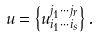<formula> <loc_0><loc_0><loc_500><loc_500>u = \left \{ u ^ { j _ { 1 } \cdots j _ { r } } _ { i _ { 1 } \cdots i _ { s } } \right \} .</formula> 